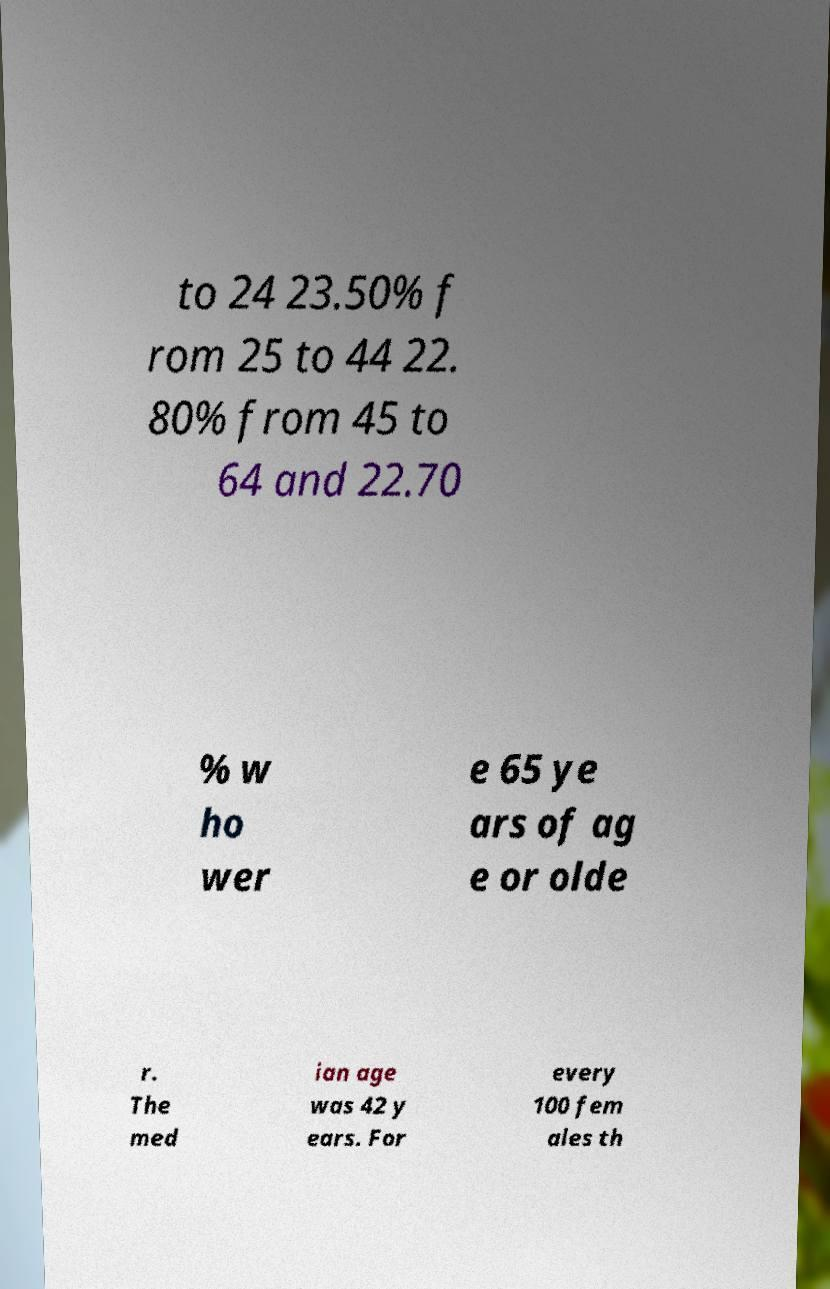There's text embedded in this image that I need extracted. Can you transcribe it verbatim? to 24 23.50% f rom 25 to 44 22. 80% from 45 to 64 and 22.70 % w ho wer e 65 ye ars of ag e or olde r. The med ian age was 42 y ears. For every 100 fem ales th 